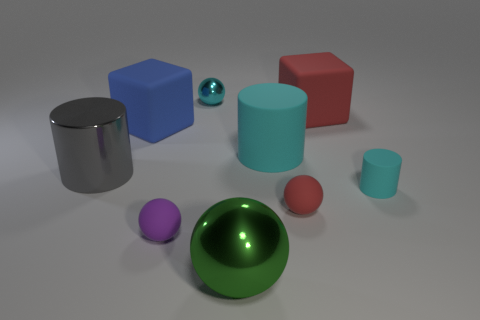Subtract all small spheres. How many spheres are left? 1 Subtract all cyan blocks. How many cyan cylinders are left? 2 Subtract all green spheres. How many spheres are left? 3 Subtract 1 balls. How many balls are left? 3 Add 7 small yellow cylinders. How many small yellow cylinders exist? 7 Subtract 1 red balls. How many objects are left? 8 Subtract all cylinders. How many objects are left? 6 Subtract all brown cylinders. Subtract all yellow spheres. How many cylinders are left? 3 Subtract all blue blocks. Subtract all cubes. How many objects are left? 6 Add 1 large gray metal cylinders. How many large gray metal cylinders are left? 2 